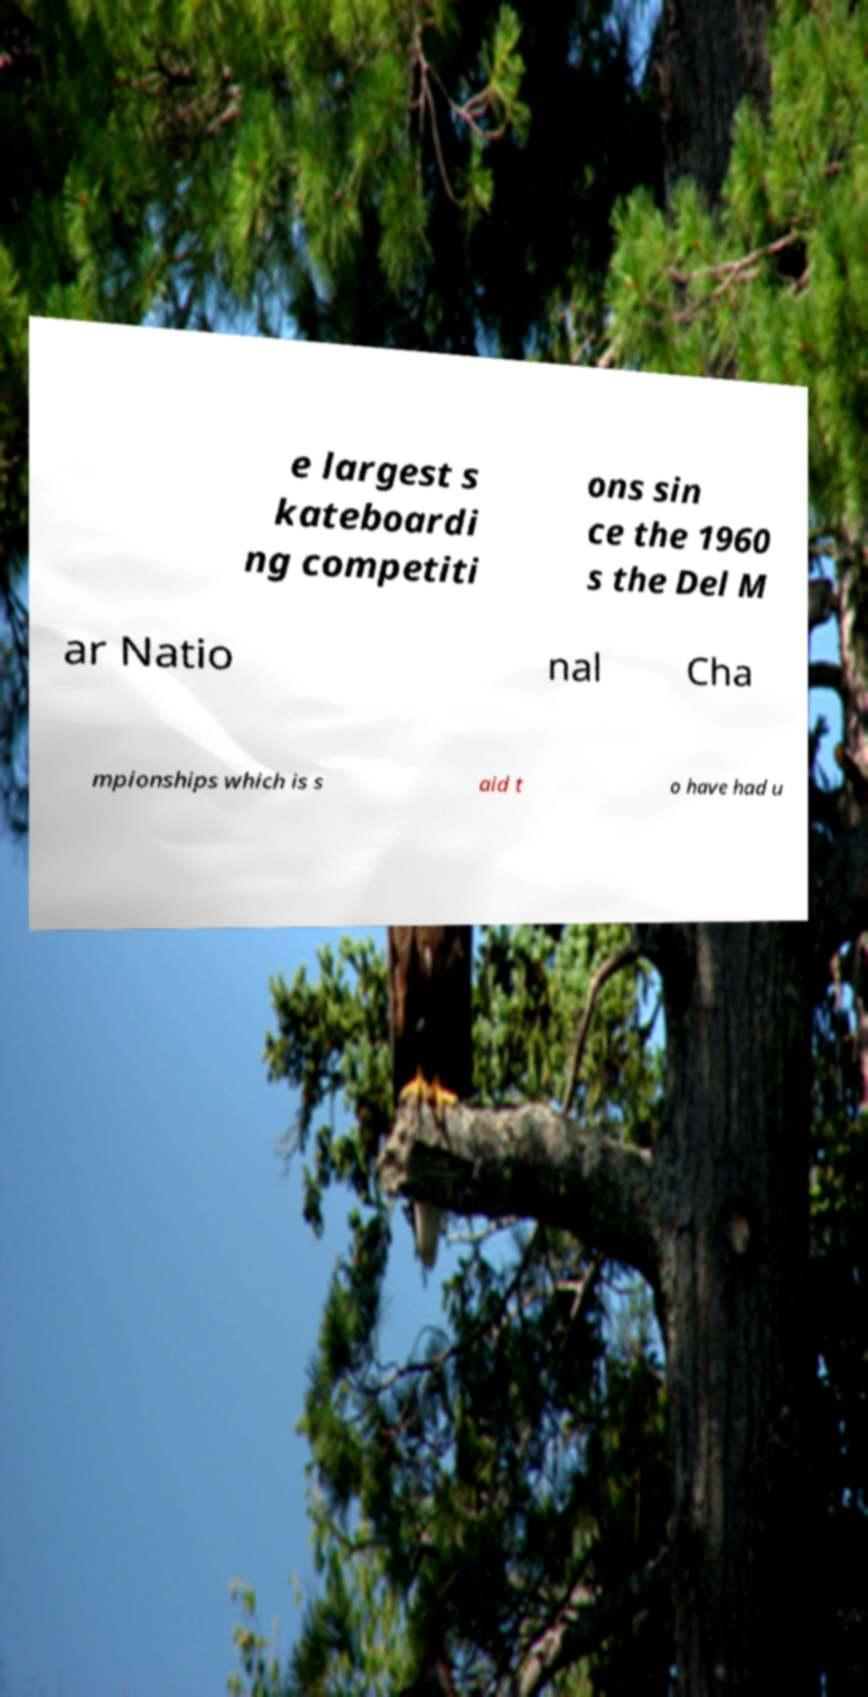Can you read and provide the text displayed in the image?This photo seems to have some interesting text. Can you extract and type it out for me? e largest s kateboardi ng competiti ons sin ce the 1960 s the Del M ar Natio nal Cha mpionships which is s aid t o have had u 